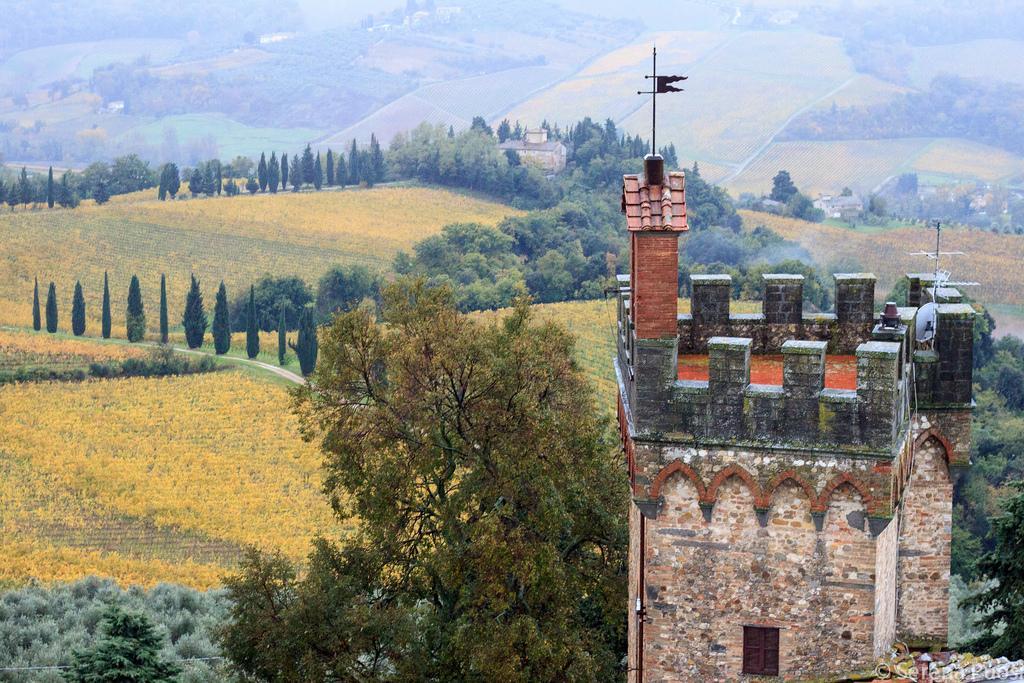Please provide a concise description of this image. In this picture there are buildings and trees and fields and there is a flag on the top of the building. At the bottom right there is a text. 